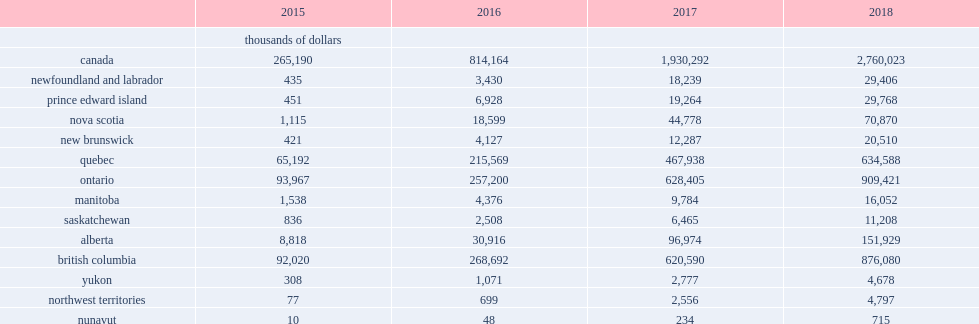Using the methodology previously-outlined, what is the revenue for the private short-term accommodation market in canada in 2018? 2760023.0. Of all the provinces and territories, nunavut experienced the fastest growth in private short-term accommodation, how many revenues increased from in 2015? 10.0. Of all the provinces and territories, nunavut experienced the fastest growth in private short-term accommodation, how many revenues increased to in 2018? 715.0. 